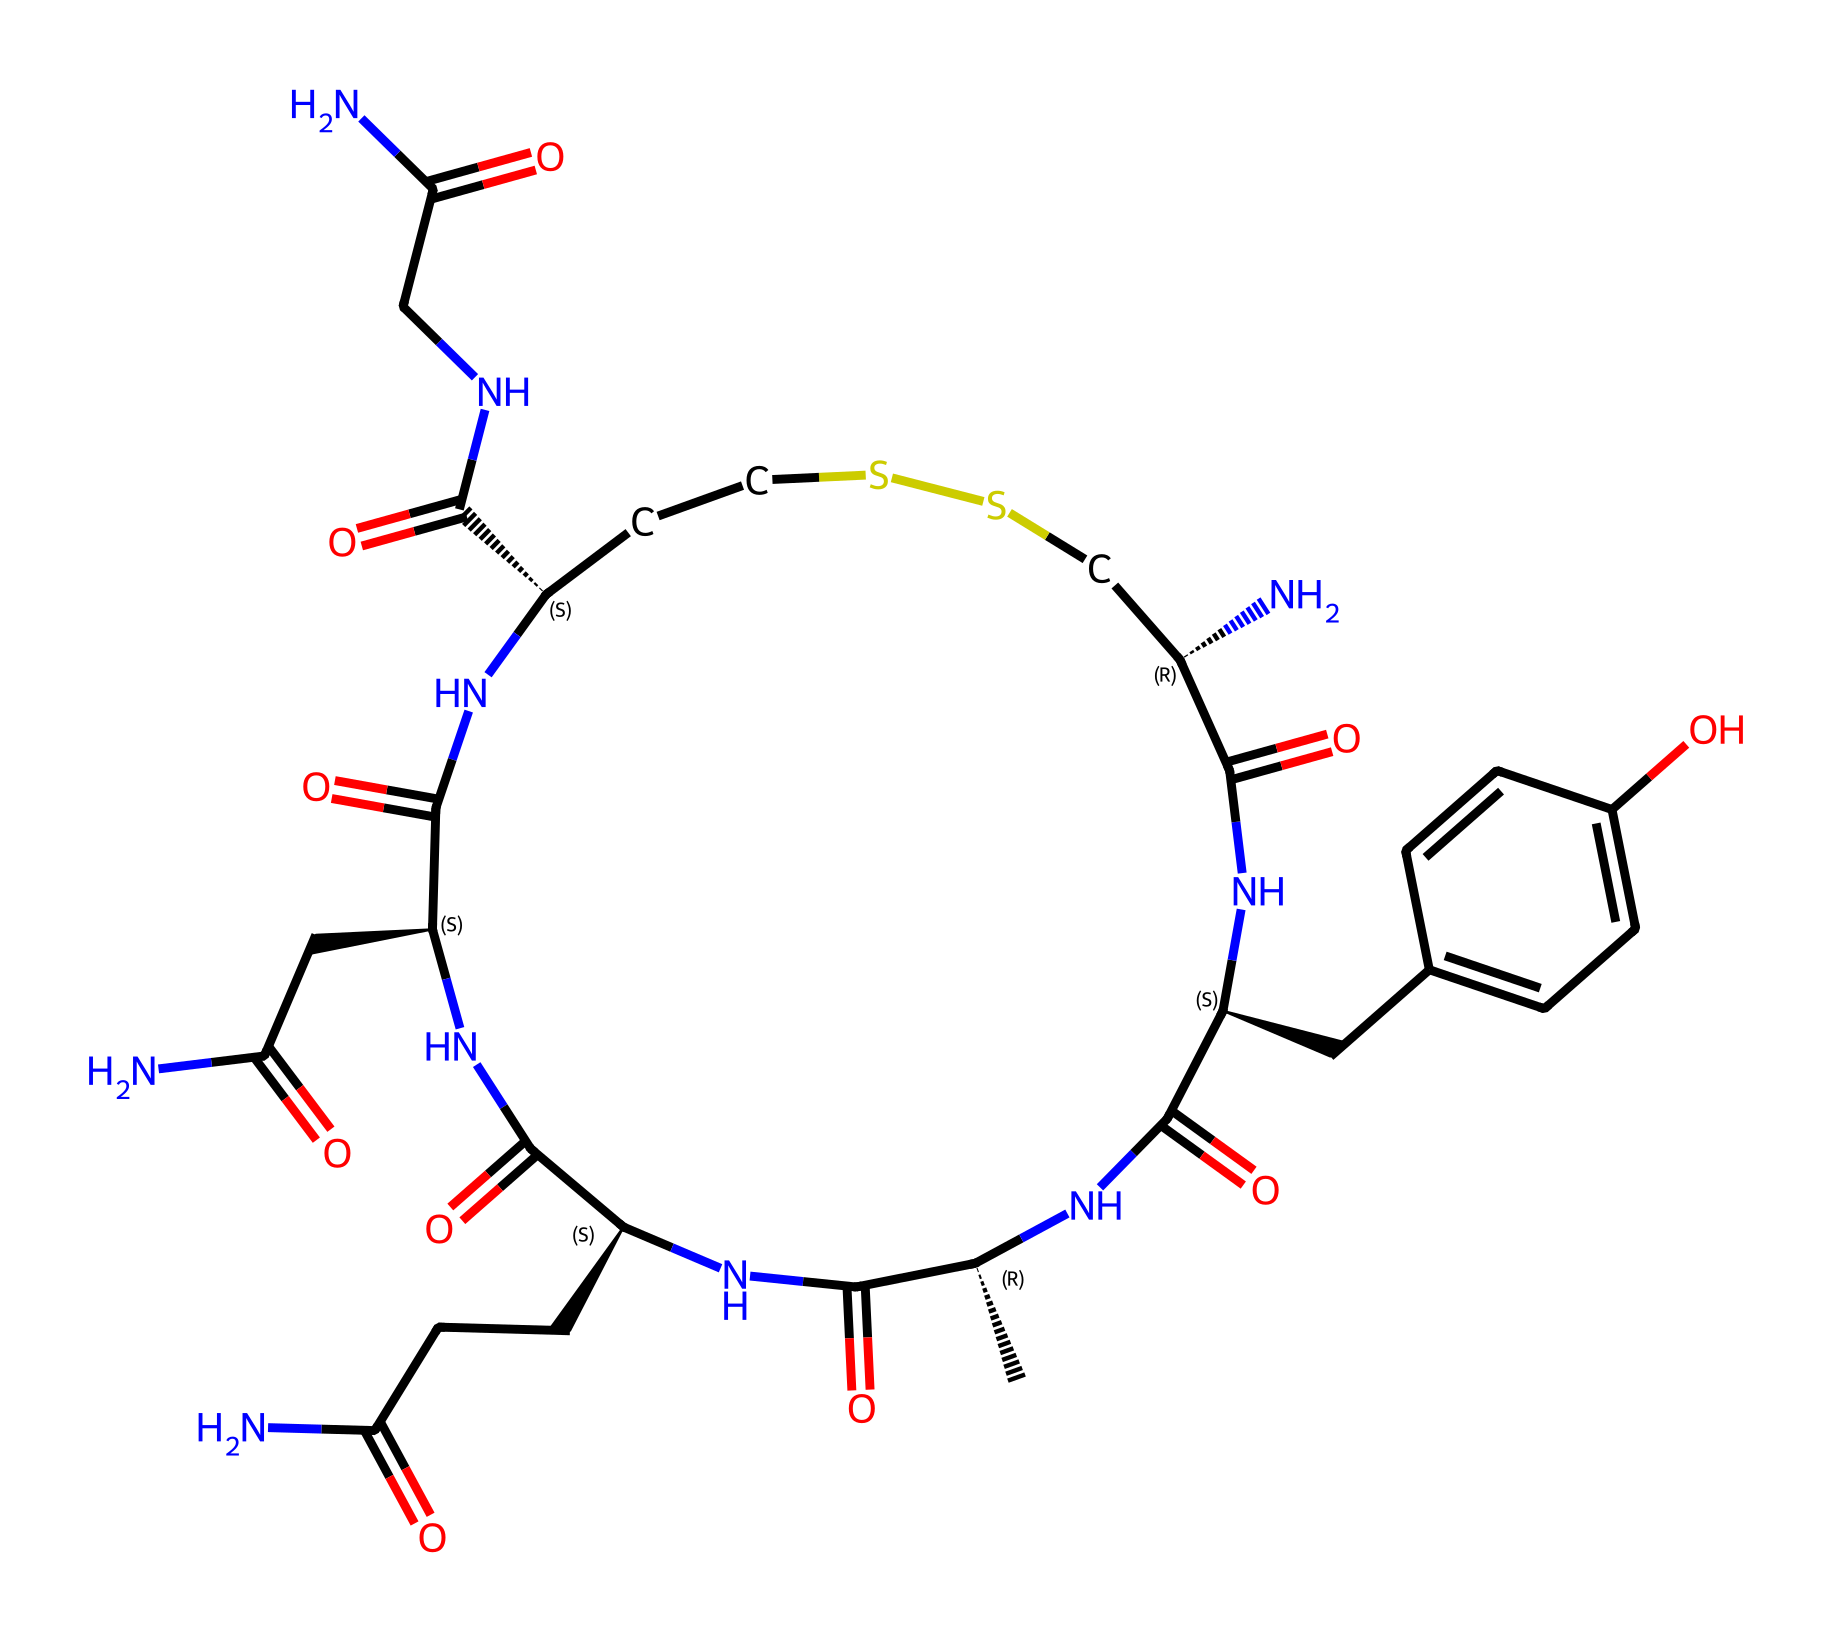What is the molecular formula of oxytocin? The SMILES representation can be translated into its molecular formula, which indicates the total number of each type of atom present in the compound. In this case, counting the atoms represented by the SMILES string leads to a molecular formula of C43H66N12O12S2.
Answer: C43H66N12O12S2 How many nitrogen atoms are present in the structure? By examining the structure detailed in the SMILES representation, we can identify all the nitrogen (N) atoms. In this case, the representation indicates there are a total of 12 nitrogen atoms present.
Answer: 12 What functional groups can be found in oxytocin? Analyzing the SMILES representation, we can identify several functional groups based on the presence of specific atoms and their bonding patterns, such as amides (C(=O)N) and disulfide (S-S) linkages. This indicates that oxytocin includes multiple amide and disulfide functional groups.
Answer: amide, disulfide How many chiral centers are in oxytocin? Looking at the chiral centers indicated by the '@' symbols in the SMILES structure, we see there are four '@' symbols, each representing a chiral center where the spatial arrangement of atoms allows for different configurations. Therefore, there are four chiral centers in oxytocin.
Answer: 4 What type of chemical is oxytocin? Reviewing the structure and recognizing the functions and behaviors associated with this molecule, this chemical is classified as a peptide hormone due to its biological function and the presence of amino acid residues in its structure.
Answer: peptide hormone What is the role of oxytocin in the human body? Understanding the biological functions associated with oxytocin, such as its role in social bonding, childbirth, and lactation, reveals that it is crucial for maternal behaviors and emotional connections. This action stems from its classification as a hormone involved in interpersonal trust and emotional bonding.
Answer: social bonding 